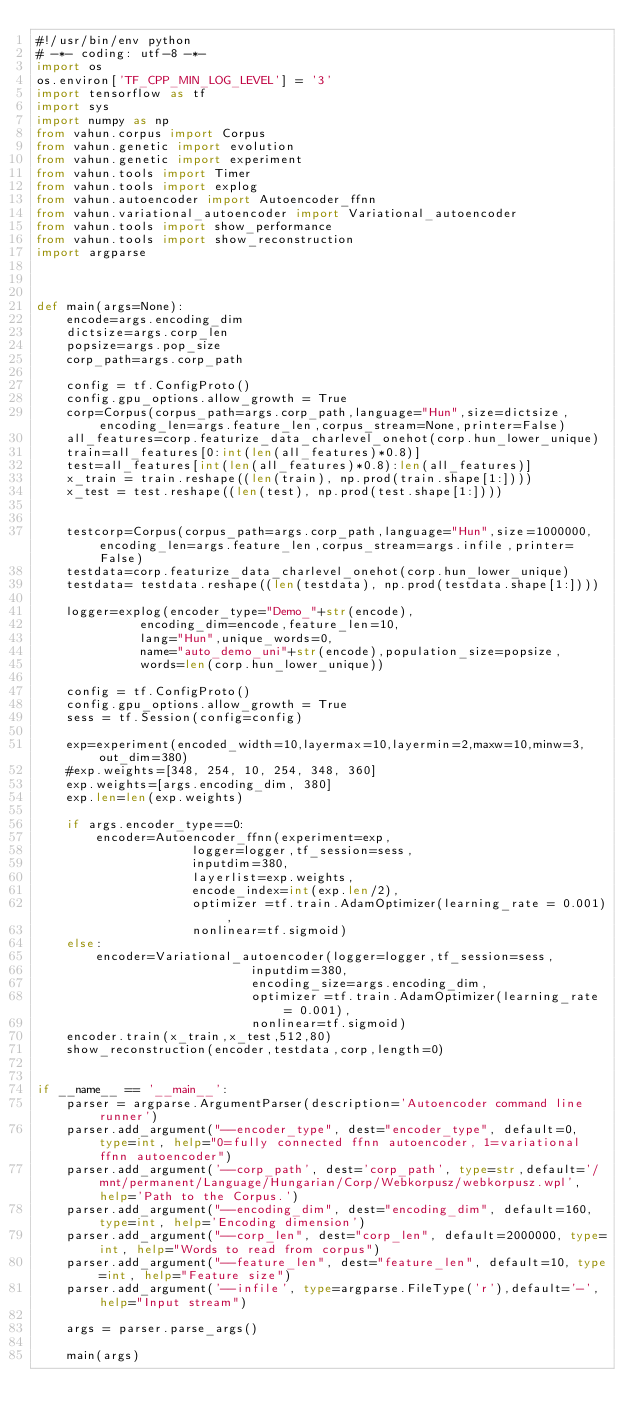<code> <loc_0><loc_0><loc_500><loc_500><_Python_>#!/usr/bin/env python
# -*- coding: utf-8 -*-
import os
os.environ['TF_CPP_MIN_LOG_LEVEL'] = '3'
import tensorflow as tf
import sys
import numpy as np
from vahun.corpus import Corpus
from vahun.genetic import evolution
from vahun.genetic import experiment
from vahun.tools import Timer
from vahun.tools import explog
from vahun.autoencoder import Autoencoder_ffnn
from vahun.variational_autoencoder import Variational_autoencoder
from vahun.tools import show_performance
from vahun.tools import show_reconstruction
import argparse



def main(args=None):
    encode=args.encoding_dim
    dictsize=args.corp_len
    popsize=args.pop_size
    corp_path=args.corp_path

    config = tf.ConfigProto()
    config.gpu_options.allow_growth = True
    corp=Corpus(corpus_path=args.corp_path,language="Hun",size=dictsize,encoding_len=args.feature_len,corpus_stream=None,printer=False)
    all_features=corp.featurize_data_charlevel_onehot(corp.hun_lower_unique)
    train=all_features[0:int(len(all_features)*0.8)]
    test=all_features[int(len(all_features)*0.8):len(all_features)]
    x_train = train.reshape((len(train), np.prod(train.shape[1:])))
    x_test = test.reshape((len(test), np.prod(test.shape[1:])))
    
    
    testcorp=Corpus(corpus_path=args.corp_path,language="Hun",size=1000000,encoding_len=args.feature_len,corpus_stream=args.infile,printer=False)
    testdata=corp.featurize_data_charlevel_onehot(corp.hun_lower_unique)
    testdata= testdata.reshape((len(testdata), np.prod(testdata.shape[1:])))
    
    logger=explog(encoder_type="Demo_"+str(encode),
              encoding_dim=encode,feature_len=10,
              lang="Hun",unique_words=0,
              name="auto_demo_uni"+str(encode),population_size=popsize,
              words=len(corp.hun_lower_unique))

    config = tf.ConfigProto()
    config.gpu_options.allow_growth = True
    sess = tf.Session(config=config)

    exp=experiment(encoded_width=10,layermax=10,layermin=2,maxw=10,minw=3,out_dim=380)
    #exp.weights=[348, 254, 10, 254, 348, 360]
    exp.weights=[args.encoding_dim, 380]
    exp.len=len(exp.weights)
    
    if args.encoder_type==0:
        encoder=Autoencoder_ffnn(experiment=exp,
                     logger=logger,tf_session=sess,
                     inputdim=380,
                     layerlist=exp.weights,
                     encode_index=int(exp.len/2),
                     optimizer =tf.train.AdamOptimizer(learning_rate = 0.001),
                     nonlinear=tf.sigmoid)
    else:
        encoder=Variational_autoencoder(logger=logger,tf_session=sess,
                             inputdim=380,
                             encoding_size=args.encoding_dim,
                             optimizer =tf.train.AdamOptimizer(learning_rate = 0.001),
                             nonlinear=tf.sigmoid)
    encoder.train(x_train,x_test,512,80)
    show_reconstruction(encoder,testdata,corp,length=0)


if __name__ == '__main__':
    parser = argparse.ArgumentParser(description='Autoencoder command line runner')
    parser.add_argument("--encoder_type", dest="encoder_type", default=0, type=int, help="0=fully connected ffnn autoencoder, 1=variational ffnn autoencoder")
    parser.add_argument('--corp_path', dest='corp_path', type=str,default='/mnt/permanent/Language/Hungarian/Corp/Webkorpusz/webkorpusz.wpl',help='Path to the Corpus.')
    parser.add_argument("--encoding_dim", dest="encoding_dim", default=160, type=int, help='Encoding dimension')
    parser.add_argument("--corp_len", dest="corp_len", default=2000000, type=int, help="Words to read from corpus")
    parser.add_argument("--feature_len", dest="feature_len", default=10, type=int, help="Feature size")
    parser.add_argument('--infile', type=argparse.FileType('r'),default='-',help="Input stream")
    
    args = parser.parse_args()

    main(args)</code> 